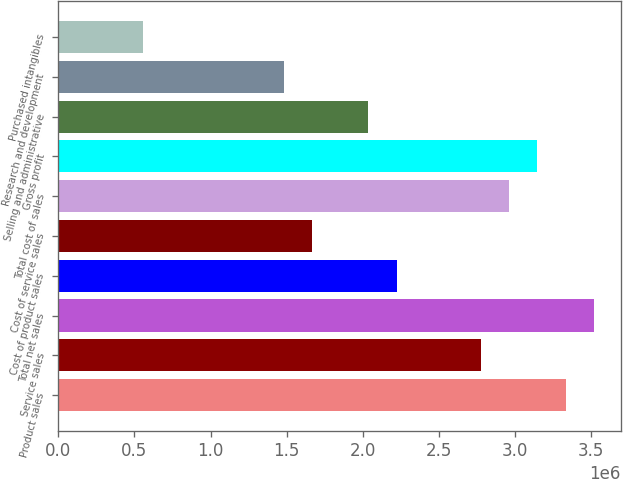Convert chart. <chart><loc_0><loc_0><loc_500><loc_500><bar_chart><fcel>Product sales<fcel>Service sales<fcel>Total net sales<fcel>Cost of product sales<fcel>Cost of service sales<fcel>Total cost of sales<fcel>Gross profit<fcel>Selling and administrative<fcel>Research and development<fcel>Purchased intangibles<nl><fcel>3.33213e+06<fcel>2.77677e+06<fcel>3.51725e+06<fcel>2.22142e+06<fcel>1.66607e+06<fcel>2.96189e+06<fcel>3.14701e+06<fcel>2.0363e+06<fcel>1.48095e+06<fcel>555358<nl></chart> 